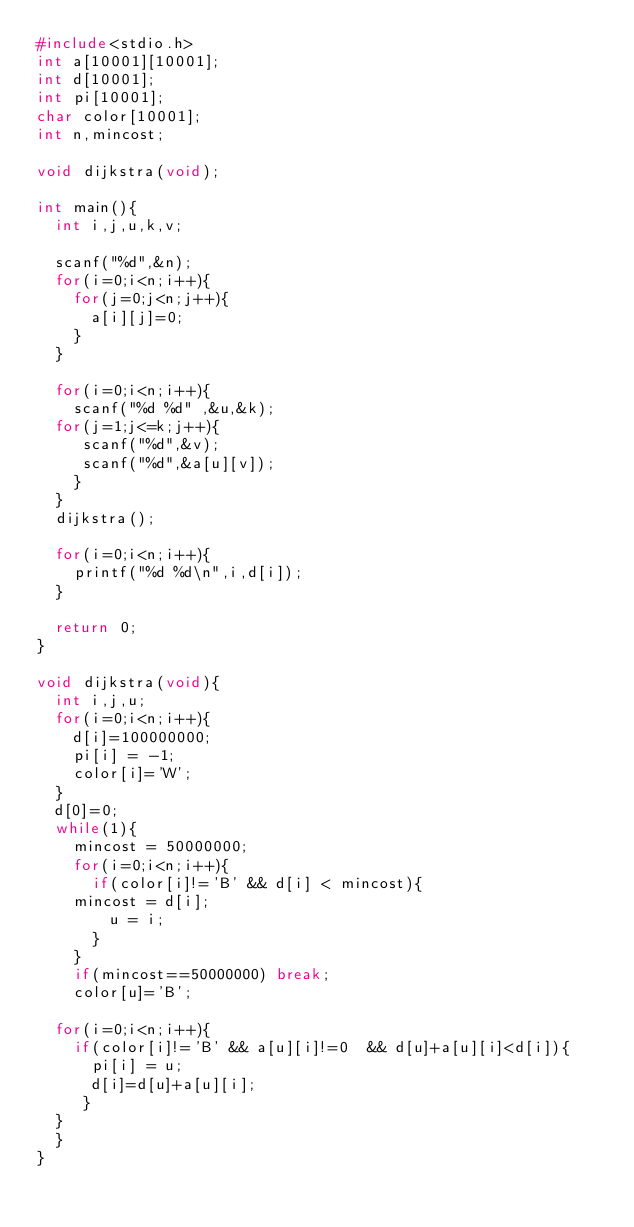Convert code to text. <code><loc_0><loc_0><loc_500><loc_500><_C_>#include<stdio.h>
int a[10001][10001];
int d[10001];
int pi[10001];
char color[10001];
int n,mincost;

void dijkstra(void);

int main(){
  int i,j,u,k,v;

  scanf("%d",&n);
  for(i=0;i<n;i++){
    for(j=0;j<n;j++){
      a[i][j]=0;
    }
  }

  for(i=0;i<n;i++){
    scanf("%d %d" ,&u,&k);      
  for(j=1;j<=k;j++){
     scanf("%d",&v);
     scanf("%d",&a[u][v]);   
    }
  }
  dijkstra();

  for(i=0;i<n;i++){
    printf("%d %d\n",i,d[i]);
  }

  return 0;
}

void dijkstra(void){
  int i,j,u;
  for(i=0;i<n;i++){
    d[i]=100000000;
    pi[i] = -1;
    color[i]='W';
  }
  d[0]=0;
  while(1){
    mincost = 50000000;
    for(i=0;i<n;i++){
      if(color[i]!='B' && d[i] < mincost){
	mincost = d[i];
        u = i;
      }
    }
    if(mincost==50000000) break;
    color[u]='B';
  
  for(i=0;i<n;i++){
    if(color[i]!='B' && a[u][i]!=0  && d[u]+a[u][i]<d[i]){
      pi[i] = u;
      d[i]=d[u]+a[u][i];
     }
  }
  }
}</code> 